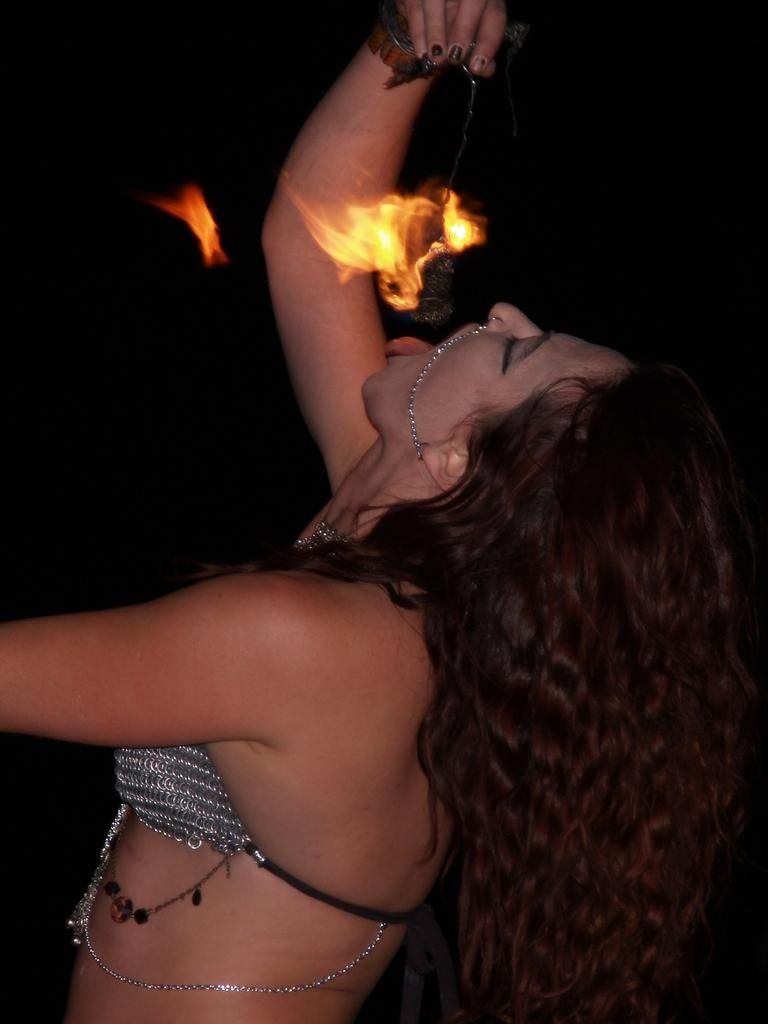Who is the main subject in the image? There is a woman in the image. What is the woman doing in the image? The woman is standing over a place and trying to eat something in her hand. What is unique about the object in her hand? The object in her hand is on fire. What type of silk fabric is draped over the woman's shoulder in the image? There is no silk fabric present in the image. 